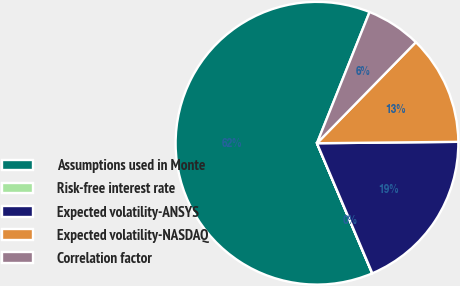Convert chart. <chart><loc_0><loc_0><loc_500><loc_500><pie_chart><fcel>Assumptions used in Monte<fcel>Risk-free interest rate<fcel>Expected volatility-ANSYS<fcel>Expected volatility-NASDAQ<fcel>Correlation factor<nl><fcel>62.45%<fcel>0.02%<fcel>18.75%<fcel>12.51%<fcel>6.26%<nl></chart> 